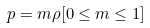Convert formula to latex. <formula><loc_0><loc_0><loc_500><loc_500>p = m \rho [ 0 \leq m \leq 1 ]</formula> 